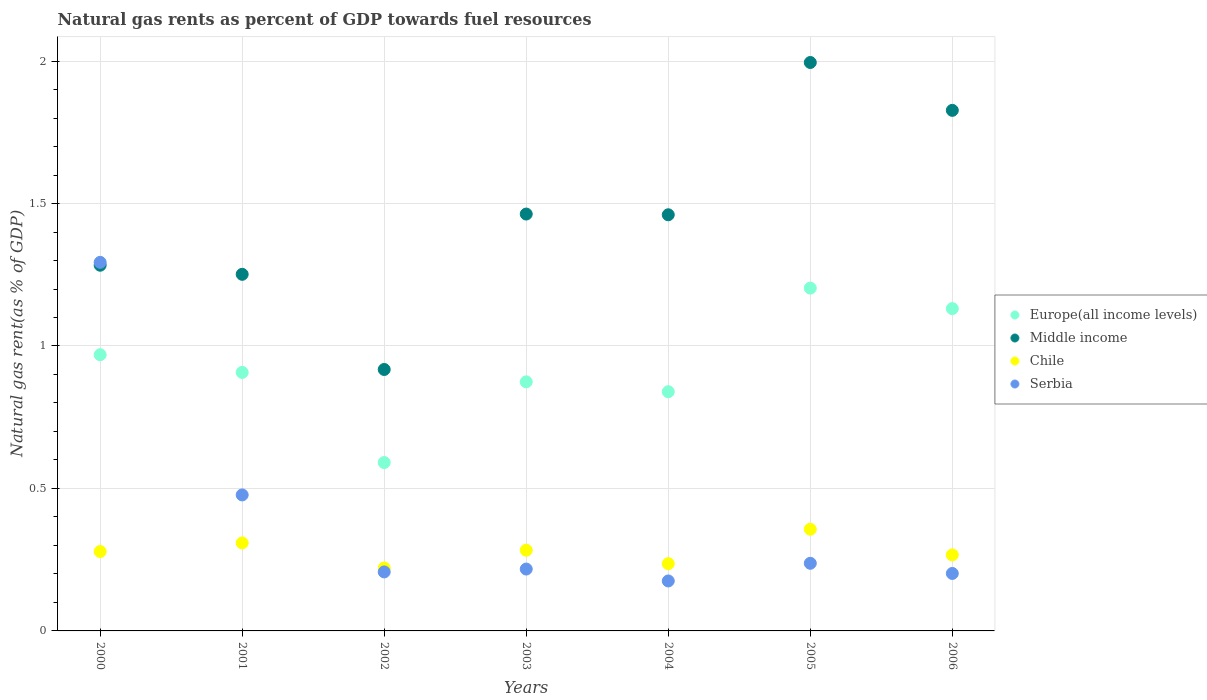How many different coloured dotlines are there?
Provide a succinct answer. 4. Is the number of dotlines equal to the number of legend labels?
Your answer should be compact. Yes. What is the natural gas rent in Serbia in 2002?
Offer a terse response. 0.21. Across all years, what is the maximum natural gas rent in Serbia?
Give a very brief answer. 1.29. Across all years, what is the minimum natural gas rent in Serbia?
Provide a succinct answer. 0.18. What is the total natural gas rent in Europe(all income levels) in the graph?
Ensure brevity in your answer.  6.52. What is the difference between the natural gas rent in Chile in 2001 and that in 2004?
Your response must be concise. 0.07. What is the difference between the natural gas rent in Serbia in 2003 and the natural gas rent in Europe(all income levels) in 2000?
Provide a short and direct response. -0.75. What is the average natural gas rent in Chile per year?
Provide a short and direct response. 0.28. In the year 2001, what is the difference between the natural gas rent in Middle income and natural gas rent in Europe(all income levels)?
Keep it short and to the point. 0.34. What is the ratio of the natural gas rent in Serbia in 2000 to that in 2002?
Your answer should be compact. 6.25. Is the difference between the natural gas rent in Middle income in 2003 and 2005 greater than the difference between the natural gas rent in Europe(all income levels) in 2003 and 2005?
Your answer should be compact. No. What is the difference between the highest and the second highest natural gas rent in Serbia?
Make the answer very short. 0.82. What is the difference between the highest and the lowest natural gas rent in Serbia?
Provide a succinct answer. 1.12. Is the natural gas rent in Europe(all income levels) strictly greater than the natural gas rent in Chile over the years?
Keep it short and to the point. Yes. What is the difference between two consecutive major ticks on the Y-axis?
Offer a terse response. 0.5. Where does the legend appear in the graph?
Your answer should be very brief. Center right. How many legend labels are there?
Ensure brevity in your answer.  4. How are the legend labels stacked?
Keep it short and to the point. Vertical. What is the title of the graph?
Offer a terse response. Natural gas rents as percent of GDP towards fuel resources. What is the label or title of the X-axis?
Ensure brevity in your answer.  Years. What is the label or title of the Y-axis?
Offer a terse response. Natural gas rent(as % of GDP). What is the Natural gas rent(as % of GDP) of Europe(all income levels) in 2000?
Give a very brief answer. 0.97. What is the Natural gas rent(as % of GDP) of Middle income in 2000?
Offer a very short reply. 1.28. What is the Natural gas rent(as % of GDP) in Chile in 2000?
Your answer should be compact. 0.28. What is the Natural gas rent(as % of GDP) of Serbia in 2000?
Provide a short and direct response. 1.29. What is the Natural gas rent(as % of GDP) of Europe(all income levels) in 2001?
Provide a succinct answer. 0.91. What is the Natural gas rent(as % of GDP) in Middle income in 2001?
Keep it short and to the point. 1.25. What is the Natural gas rent(as % of GDP) in Chile in 2001?
Provide a short and direct response. 0.31. What is the Natural gas rent(as % of GDP) of Serbia in 2001?
Provide a short and direct response. 0.48. What is the Natural gas rent(as % of GDP) of Europe(all income levels) in 2002?
Make the answer very short. 0.59. What is the Natural gas rent(as % of GDP) in Middle income in 2002?
Provide a short and direct response. 0.92. What is the Natural gas rent(as % of GDP) in Chile in 2002?
Offer a terse response. 0.22. What is the Natural gas rent(as % of GDP) of Serbia in 2002?
Offer a terse response. 0.21. What is the Natural gas rent(as % of GDP) in Europe(all income levels) in 2003?
Provide a succinct answer. 0.87. What is the Natural gas rent(as % of GDP) in Middle income in 2003?
Give a very brief answer. 1.46. What is the Natural gas rent(as % of GDP) in Chile in 2003?
Offer a very short reply. 0.28. What is the Natural gas rent(as % of GDP) of Serbia in 2003?
Provide a short and direct response. 0.22. What is the Natural gas rent(as % of GDP) of Europe(all income levels) in 2004?
Offer a very short reply. 0.84. What is the Natural gas rent(as % of GDP) in Middle income in 2004?
Your answer should be very brief. 1.46. What is the Natural gas rent(as % of GDP) in Chile in 2004?
Offer a terse response. 0.24. What is the Natural gas rent(as % of GDP) of Serbia in 2004?
Provide a short and direct response. 0.18. What is the Natural gas rent(as % of GDP) in Europe(all income levels) in 2005?
Provide a succinct answer. 1.2. What is the Natural gas rent(as % of GDP) of Middle income in 2005?
Your response must be concise. 1.99. What is the Natural gas rent(as % of GDP) in Chile in 2005?
Offer a terse response. 0.36. What is the Natural gas rent(as % of GDP) in Serbia in 2005?
Provide a succinct answer. 0.24. What is the Natural gas rent(as % of GDP) in Europe(all income levels) in 2006?
Provide a succinct answer. 1.13. What is the Natural gas rent(as % of GDP) of Middle income in 2006?
Offer a very short reply. 1.83. What is the Natural gas rent(as % of GDP) of Chile in 2006?
Provide a succinct answer. 0.27. What is the Natural gas rent(as % of GDP) of Serbia in 2006?
Offer a terse response. 0.2. Across all years, what is the maximum Natural gas rent(as % of GDP) of Europe(all income levels)?
Your answer should be compact. 1.2. Across all years, what is the maximum Natural gas rent(as % of GDP) of Middle income?
Provide a short and direct response. 1.99. Across all years, what is the maximum Natural gas rent(as % of GDP) in Chile?
Your response must be concise. 0.36. Across all years, what is the maximum Natural gas rent(as % of GDP) in Serbia?
Ensure brevity in your answer.  1.29. Across all years, what is the minimum Natural gas rent(as % of GDP) in Europe(all income levels)?
Offer a terse response. 0.59. Across all years, what is the minimum Natural gas rent(as % of GDP) of Middle income?
Your answer should be very brief. 0.92. Across all years, what is the minimum Natural gas rent(as % of GDP) in Chile?
Keep it short and to the point. 0.22. Across all years, what is the minimum Natural gas rent(as % of GDP) of Serbia?
Provide a succinct answer. 0.18. What is the total Natural gas rent(as % of GDP) of Europe(all income levels) in the graph?
Your answer should be compact. 6.52. What is the total Natural gas rent(as % of GDP) in Middle income in the graph?
Provide a succinct answer. 10.2. What is the total Natural gas rent(as % of GDP) in Chile in the graph?
Give a very brief answer. 1.95. What is the total Natural gas rent(as % of GDP) of Serbia in the graph?
Ensure brevity in your answer.  2.81. What is the difference between the Natural gas rent(as % of GDP) of Europe(all income levels) in 2000 and that in 2001?
Your response must be concise. 0.06. What is the difference between the Natural gas rent(as % of GDP) in Middle income in 2000 and that in 2001?
Ensure brevity in your answer.  0.03. What is the difference between the Natural gas rent(as % of GDP) of Chile in 2000 and that in 2001?
Your answer should be compact. -0.03. What is the difference between the Natural gas rent(as % of GDP) of Serbia in 2000 and that in 2001?
Provide a short and direct response. 0.82. What is the difference between the Natural gas rent(as % of GDP) in Europe(all income levels) in 2000 and that in 2002?
Give a very brief answer. 0.38. What is the difference between the Natural gas rent(as % of GDP) of Middle income in 2000 and that in 2002?
Your answer should be very brief. 0.37. What is the difference between the Natural gas rent(as % of GDP) in Chile in 2000 and that in 2002?
Offer a very short reply. 0.06. What is the difference between the Natural gas rent(as % of GDP) in Serbia in 2000 and that in 2002?
Give a very brief answer. 1.09. What is the difference between the Natural gas rent(as % of GDP) of Europe(all income levels) in 2000 and that in 2003?
Provide a succinct answer. 0.1. What is the difference between the Natural gas rent(as % of GDP) in Middle income in 2000 and that in 2003?
Give a very brief answer. -0.18. What is the difference between the Natural gas rent(as % of GDP) of Chile in 2000 and that in 2003?
Provide a succinct answer. -0. What is the difference between the Natural gas rent(as % of GDP) in Serbia in 2000 and that in 2003?
Make the answer very short. 1.08. What is the difference between the Natural gas rent(as % of GDP) of Europe(all income levels) in 2000 and that in 2004?
Your answer should be very brief. 0.13. What is the difference between the Natural gas rent(as % of GDP) in Middle income in 2000 and that in 2004?
Keep it short and to the point. -0.18. What is the difference between the Natural gas rent(as % of GDP) of Chile in 2000 and that in 2004?
Offer a terse response. 0.04. What is the difference between the Natural gas rent(as % of GDP) of Serbia in 2000 and that in 2004?
Provide a succinct answer. 1.12. What is the difference between the Natural gas rent(as % of GDP) of Europe(all income levels) in 2000 and that in 2005?
Give a very brief answer. -0.23. What is the difference between the Natural gas rent(as % of GDP) in Middle income in 2000 and that in 2005?
Give a very brief answer. -0.71. What is the difference between the Natural gas rent(as % of GDP) in Chile in 2000 and that in 2005?
Make the answer very short. -0.08. What is the difference between the Natural gas rent(as % of GDP) of Serbia in 2000 and that in 2005?
Give a very brief answer. 1.06. What is the difference between the Natural gas rent(as % of GDP) in Europe(all income levels) in 2000 and that in 2006?
Provide a succinct answer. -0.16. What is the difference between the Natural gas rent(as % of GDP) of Middle income in 2000 and that in 2006?
Offer a terse response. -0.54. What is the difference between the Natural gas rent(as % of GDP) of Chile in 2000 and that in 2006?
Make the answer very short. 0.01. What is the difference between the Natural gas rent(as % of GDP) of Serbia in 2000 and that in 2006?
Your response must be concise. 1.09. What is the difference between the Natural gas rent(as % of GDP) in Europe(all income levels) in 2001 and that in 2002?
Provide a succinct answer. 0.32. What is the difference between the Natural gas rent(as % of GDP) of Middle income in 2001 and that in 2002?
Your response must be concise. 0.33. What is the difference between the Natural gas rent(as % of GDP) of Chile in 2001 and that in 2002?
Offer a very short reply. 0.09. What is the difference between the Natural gas rent(as % of GDP) of Serbia in 2001 and that in 2002?
Make the answer very short. 0.27. What is the difference between the Natural gas rent(as % of GDP) of Europe(all income levels) in 2001 and that in 2003?
Your response must be concise. 0.03. What is the difference between the Natural gas rent(as % of GDP) in Middle income in 2001 and that in 2003?
Your response must be concise. -0.21. What is the difference between the Natural gas rent(as % of GDP) of Chile in 2001 and that in 2003?
Provide a succinct answer. 0.03. What is the difference between the Natural gas rent(as % of GDP) of Serbia in 2001 and that in 2003?
Provide a short and direct response. 0.26. What is the difference between the Natural gas rent(as % of GDP) in Europe(all income levels) in 2001 and that in 2004?
Provide a succinct answer. 0.07. What is the difference between the Natural gas rent(as % of GDP) of Middle income in 2001 and that in 2004?
Your answer should be compact. -0.21. What is the difference between the Natural gas rent(as % of GDP) of Chile in 2001 and that in 2004?
Provide a succinct answer. 0.07. What is the difference between the Natural gas rent(as % of GDP) in Serbia in 2001 and that in 2004?
Provide a short and direct response. 0.3. What is the difference between the Natural gas rent(as % of GDP) in Europe(all income levels) in 2001 and that in 2005?
Your answer should be compact. -0.3. What is the difference between the Natural gas rent(as % of GDP) in Middle income in 2001 and that in 2005?
Provide a succinct answer. -0.74. What is the difference between the Natural gas rent(as % of GDP) of Chile in 2001 and that in 2005?
Provide a short and direct response. -0.05. What is the difference between the Natural gas rent(as % of GDP) in Serbia in 2001 and that in 2005?
Keep it short and to the point. 0.24. What is the difference between the Natural gas rent(as % of GDP) of Europe(all income levels) in 2001 and that in 2006?
Offer a very short reply. -0.22. What is the difference between the Natural gas rent(as % of GDP) of Middle income in 2001 and that in 2006?
Make the answer very short. -0.58. What is the difference between the Natural gas rent(as % of GDP) in Chile in 2001 and that in 2006?
Provide a succinct answer. 0.04. What is the difference between the Natural gas rent(as % of GDP) in Serbia in 2001 and that in 2006?
Give a very brief answer. 0.28. What is the difference between the Natural gas rent(as % of GDP) in Europe(all income levels) in 2002 and that in 2003?
Your response must be concise. -0.28. What is the difference between the Natural gas rent(as % of GDP) in Middle income in 2002 and that in 2003?
Provide a short and direct response. -0.55. What is the difference between the Natural gas rent(as % of GDP) in Chile in 2002 and that in 2003?
Offer a very short reply. -0.06. What is the difference between the Natural gas rent(as % of GDP) in Serbia in 2002 and that in 2003?
Offer a terse response. -0.01. What is the difference between the Natural gas rent(as % of GDP) in Europe(all income levels) in 2002 and that in 2004?
Give a very brief answer. -0.25. What is the difference between the Natural gas rent(as % of GDP) of Middle income in 2002 and that in 2004?
Ensure brevity in your answer.  -0.54. What is the difference between the Natural gas rent(as % of GDP) of Chile in 2002 and that in 2004?
Give a very brief answer. -0.02. What is the difference between the Natural gas rent(as % of GDP) in Serbia in 2002 and that in 2004?
Provide a short and direct response. 0.03. What is the difference between the Natural gas rent(as % of GDP) of Europe(all income levels) in 2002 and that in 2005?
Make the answer very short. -0.61. What is the difference between the Natural gas rent(as % of GDP) of Middle income in 2002 and that in 2005?
Your answer should be compact. -1.08. What is the difference between the Natural gas rent(as % of GDP) of Chile in 2002 and that in 2005?
Your response must be concise. -0.14. What is the difference between the Natural gas rent(as % of GDP) of Serbia in 2002 and that in 2005?
Provide a succinct answer. -0.03. What is the difference between the Natural gas rent(as % of GDP) in Europe(all income levels) in 2002 and that in 2006?
Make the answer very short. -0.54. What is the difference between the Natural gas rent(as % of GDP) of Middle income in 2002 and that in 2006?
Your answer should be compact. -0.91. What is the difference between the Natural gas rent(as % of GDP) of Chile in 2002 and that in 2006?
Offer a terse response. -0.05. What is the difference between the Natural gas rent(as % of GDP) in Serbia in 2002 and that in 2006?
Offer a very short reply. 0.01. What is the difference between the Natural gas rent(as % of GDP) of Europe(all income levels) in 2003 and that in 2004?
Make the answer very short. 0.03. What is the difference between the Natural gas rent(as % of GDP) of Middle income in 2003 and that in 2004?
Give a very brief answer. 0. What is the difference between the Natural gas rent(as % of GDP) in Chile in 2003 and that in 2004?
Offer a very short reply. 0.05. What is the difference between the Natural gas rent(as % of GDP) in Serbia in 2003 and that in 2004?
Make the answer very short. 0.04. What is the difference between the Natural gas rent(as % of GDP) of Europe(all income levels) in 2003 and that in 2005?
Provide a short and direct response. -0.33. What is the difference between the Natural gas rent(as % of GDP) in Middle income in 2003 and that in 2005?
Provide a succinct answer. -0.53. What is the difference between the Natural gas rent(as % of GDP) in Chile in 2003 and that in 2005?
Offer a terse response. -0.07. What is the difference between the Natural gas rent(as % of GDP) of Serbia in 2003 and that in 2005?
Offer a terse response. -0.02. What is the difference between the Natural gas rent(as % of GDP) of Europe(all income levels) in 2003 and that in 2006?
Provide a succinct answer. -0.26. What is the difference between the Natural gas rent(as % of GDP) in Middle income in 2003 and that in 2006?
Offer a terse response. -0.36. What is the difference between the Natural gas rent(as % of GDP) of Chile in 2003 and that in 2006?
Make the answer very short. 0.02. What is the difference between the Natural gas rent(as % of GDP) in Serbia in 2003 and that in 2006?
Offer a very short reply. 0.02. What is the difference between the Natural gas rent(as % of GDP) of Europe(all income levels) in 2004 and that in 2005?
Provide a succinct answer. -0.36. What is the difference between the Natural gas rent(as % of GDP) in Middle income in 2004 and that in 2005?
Offer a terse response. -0.53. What is the difference between the Natural gas rent(as % of GDP) in Chile in 2004 and that in 2005?
Provide a short and direct response. -0.12. What is the difference between the Natural gas rent(as % of GDP) in Serbia in 2004 and that in 2005?
Keep it short and to the point. -0.06. What is the difference between the Natural gas rent(as % of GDP) in Europe(all income levels) in 2004 and that in 2006?
Your response must be concise. -0.29. What is the difference between the Natural gas rent(as % of GDP) in Middle income in 2004 and that in 2006?
Your answer should be compact. -0.37. What is the difference between the Natural gas rent(as % of GDP) of Chile in 2004 and that in 2006?
Keep it short and to the point. -0.03. What is the difference between the Natural gas rent(as % of GDP) of Serbia in 2004 and that in 2006?
Offer a very short reply. -0.03. What is the difference between the Natural gas rent(as % of GDP) in Europe(all income levels) in 2005 and that in 2006?
Offer a terse response. 0.07. What is the difference between the Natural gas rent(as % of GDP) in Middle income in 2005 and that in 2006?
Ensure brevity in your answer.  0.17. What is the difference between the Natural gas rent(as % of GDP) in Chile in 2005 and that in 2006?
Your response must be concise. 0.09. What is the difference between the Natural gas rent(as % of GDP) in Serbia in 2005 and that in 2006?
Keep it short and to the point. 0.04. What is the difference between the Natural gas rent(as % of GDP) in Europe(all income levels) in 2000 and the Natural gas rent(as % of GDP) in Middle income in 2001?
Offer a very short reply. -0.28. What is the difference between the Natural gas rent(as % of GDP) in Europe(all income levels) in 2000 and the Natural gas rent(as % of GDP) in Chile in 2001?
Your answer should be very brief. 0.66. What is the difference between the Natural gas rent(as % of GDP) of Europe(all income levels) in 2000 and the Natural gas rent(as % of GDP) of Serbia in 2001?
Your response must be concise. 0.49. What is the difference between the Natural gas rent(as % of GDP) of Middle income in 2000 and the Natural gas rent(as % of GDP) of Chile in 2001?
Keep it short and to the point. 0.97. What is the difference between the Natural gas rent(as % of GDP) in Middle income in 2000 and the Natural gas rent(as % of GDP) in Serbia in 2001?
Provide a succinct answer. 0.81. What is the difference between the Natural gas rent(as % of GDP) of Chile in 2000 and the Natural gas rent(as % of GDP) of Serbia in 2001?
Keep it short and to the point. -0.2. What is the difference between the Natural gas rent(as % of GDP) in Europe(all income levels) in 2000 and the Natural gas rent(as % of GDP) in Middle income in 2002?
Offer a terse response. 0.05. What is the difference between the Natural gas rent(as % of GDP) in Europe(all income levels) in 2000 and the Natural gas rent(as % of GDP) in Chile in 2002?
Offer a terse response. 0.75. What is the difference between the Natural gas rent(as % of GDP) of Europe(all income levels) in 2000 and the Natural gas rent(as % of GDP) of Serbia in 2002?
Make the answer very short. 0.76. What is the difference between the Natural gas rent(as % of GDP) of Middle income in 2000 and the Natural gas rent(as % of GDP) of Serbia in 2002?
Keep it short and to the point. 1.08. What is the difference between the Natural gas rent(as % of GDP) in Chile in 2000 and the Natural gas rent(as % of GDP) in Serbia in 2002?
Offer a terse response. 0.07. What is the difference between the Natural gas rent(as % of GDP) of Europe(all income levels) in 2000 and the Natural gas rent(as % of GDP) of Middle income in 2003?
Make the answer very short. -0.49. What is the difference between the Natural gas rent(as % of GDP) in Europe(all income levels) in 2000 and the Natural gas rent(as % of GDP) in Chile in 2003?
Provide a short and direct response. 0.69. What is the difference between the Natural gas rent(as % of GDP) in Europe(all income levels) in 2000 and the Natural gas rent(as % of GDP) in Serbia in 2003?
Ensure brevity in your answer.  0.75. What is the difference between the Natural gas rent(as % of GDP) of Middle income in 2000 and the Natural gas rent(as % of GDP) of Chile in 2003?
Provide a succinct answer. 1. What is the difference between the Natural gas rent(as % of GDP) in Middle income in 2000 and the Natural gas rent(as % of GDP) in Serbia in 2003?
Your answer should be very brief. 1.07. What is the difference between the Natural gas rent(as % of GDP) in Chile in 2000 and the Natural gas rent(as % of GDP) in Serbia in 2003?
Your answer should be very brief. 0.06. What is the difference between the Natural gas rent(as % of GDP) of Europe(all income levels) in 2000 and the Natural gas rent(as % of GDP) of Middle income in 2004?
Your answer should be very brief. -0.49. What is the difference between the Natural gas rent(as % of GDP) of Europe(all income levels) in 2000 and the Natural gas rent(as % of GDP) of Chile in 2004?
Your answer should be compact. 0.73. What is the difference between the Natural gas rent(as % of GDP) in Europe(all income levels) in 2000 and the Natural gas rent(as % of GDP) in Serbia in 2004?
Your answer should be very brief. 0.79. What is the difference between the Natural gas rent(as % of GDP) of Middle income in 2000 and the Natural gas rent(as % of GDP) of Chile in 2004?
Ensure brevity in your answer.  1.05. What is the difference between the Natural gas rent(as % of GDP) in Middle income in 2000 and the Natural gas rent(as % of GDP) in Serbia in 2004?
Provide a succinct answer. 1.11. What is the difference between the Natural gas rent(as % of GDP) of Chile in 2000 and the Natural gas rent(as % of GDP) of Serbia in 2004?
Make the answer very short. 0.1. What is the difference between the Natural gas rent(as % of GDP) in Europe(all income levels) in 2000 and the Natural gas rent(as % of GDP) in Middle income in 2005?
Your response must be concise. -1.03. What is the difference between the Natural gas rent(as % of GDP) in Europe(all income levels) in 2000 and the Natural gas rent(as % of GDP) in Chile in 2005?
Ensure brevity in your answer.  0.61. What is the difference between the Natural gas rent(as % of GDP) of Europe(all income levels) in 2000 and the Natural gas rent(as % of GDP) of Serbia in 2005?
Keep it short and to the point. 0.73. What is the difference between the Natural gas rent(as % of GDP) of Middle income in 2000 and the Natural gas rent(as % of GDP) of Chile in 2005?
Your answer should be very brief. 0.93. What is the difference between the Natural gas rent(as % of GDP) of Middle income in 2000 and the Natural gas rent(as % of GDP) of Serbia in 2005?
Offer a terse response. 1.05. What is the difference between the Natural gas rent(as % of GDP) in Chile in 2000 and the Natural gas rent(as % of GDP) in Serbia in 2005?
Ensure brevity in your answer.  0.04. What is the difference between the Natural gas rent(as % of GDP) of Europe(all income levels) in 2000 and the Natural gas rent(as % of GDP) of Middle income in 2006?
Give a very brief answer. -0.86. What is the difference between the Natural gas rent(as % of GDP) in Europe(all income levels) in 2000 and the Natural gas rent(as % of GDP) in Chile in 2006?
Make the answer very short. 0.7. What is the difference between the Natural gas rent(as % of GDP) of Europe(all income levels) in 2000 and the Natural gas rent(as % of GDP) of Serbia in 2006?
Your response must be concise. 0.77. What is the difference between the Natural gas rent(as % of GDP) in Middle income in 2000 and the Natural gas rent(as % of GDP) in Chile in 2006?
Offer a very short reply. 1.02. What is the difference between the Natural gas rent(as % of GDP) of Middle income in 2000 and the Natural gas rent(as % of GDP) of Serbia in 2006?
Offer a very short reply. 1.08. What is the difference between the Natural gas rent(as % of GDP) of Chile in 2000 and the Natural gas rent(as % of GDP) of Serbia in 2006?
Give a very brief answer. 0.08. What is the difference between the Natural gas rent(as % of GDP) of Europe(all income levels) in 2001 and the Natural gas rent(as % of GDP) of Middle income in 2002?
Keep it short and to the point. -0.01. What is the difference between the Natural gas rent(as % of GDP) in Europe(all income levels) in 2001 and the Natural gas rent(as % of GDP) in Chile in 2002?
Keep it short and to the point. 0.69. What is the difference between the Natural gas rent(as % of GDP) of Europe(all income levels) in 2001 and the Natural gas rent(as % of GDP) of Serbia in 2002?
Make the answer very short. 0.7. What is the difference between the Natural gas rent(as % of GDP) in Middle income in 2001 and the Natural gas rent(as % of GDP) in Chile in 2002?
Your answer should be very brief. 1.03. What is the difference between the Natural gas rent(as % of GDP) of Middle income in 2001 and the Natural gas rent(as % of GDP) of Serbia in 2002?
Offer a terse response. 1.04. What is the difference between the Natural gas rent(as % of GDP) in Chile in 2001 and the Natural gas rent(as % of GDP) in Serbia in 2002?
Your response must be concise. 0.1. What is the difference between the Natural gas rent(as % of GDP) in Europe(all income levels) in 2001 and the Natural gas rent(as % of GDP) in Middle income in 2003?
Your response must be concise. -0.56. What is the difference between the Natural gas rent(as % of GDP) of Europe(all income levels) in 2001 and the Natural gas rent(as % of GDP) of Chile in 2003?
Give a very brief answer. 0.62. What is the difference between the Natural gas rent(as % of GDP) of Europe(all income levels) in 2001 and the Natural gas rent(as % of GDP) of Serbia in 2003?
Your answer should be very brief. 0.69. What is the difference between the Natural gas rent(as % of GDP) in Middle income in 2001 and the Natural gas rent(as % of GDP) in Chile in 2003?
Your answer should be very brief. 0.97. What is the difference between the Natural gas rent(as % of GDP) of Middle income in 2001 and the Natural gas rent(as % of GDP) of Serbia in 2003?
Give a very brief answer. 1.03. What is the difference between the Natural gas rent(as % of GDP) of Chile in 2001 and the Natural gas rent(as % of GDP) of Serbia in 2003?
Make the answer very short. 0.09. What is the difference between the Natural gas rent(as % of GDP) in Europe(all income levels) in 2001 and the Natural gas rent(as % of GDP) in Middle income in 2004?
Your answer should be compact. -0.55. What is the difference between the Natural gas rent(as % of GDP) in Europe(all income levels) in 2001 and the Natural gas rent(as % of GDP) in Chile in 2004?
Make the answer very short. 0.67. What is the difference between the Natural gas rent(as % of GDP) in Europe(all income levels) in 2001 and the Natural gas rent(as % of GDP) in Serbia in 2004?
Give a very brief answer. 0.73. What is the difference between the Natural gas rent(as % of GDP) in Middle income in 2001 and the Natural gas rent(as % of GDP) in Chile in 2004?
Offer a very short reply. 1.02. What is the difference between the Natural gas rent(as % of GDP) in Middle income in 2001 and the Natural gas rent(as % of GDP) in Serbia in 2004?
Provide a succinct answer. 1.08. What is the difference between the Natural gas rent(as % of GDP) in Chile in 2001 and the Natural gas rent(as % of GDP) in Serbia in 2004?
Your answer should be compact. 0.13. What is the difference between the Natural gas rent(as % of GDP) of Europe(all income levels) in 2001 and the Natural gas rent(as % of GDP) of Middle income in 2005?
Your response must be concise. -1.09. What is the difference between the Natural gas rent(as % of GDP) in Europe(all income levels) in 2001 and the Natural gas rent(as % of GDP) in Chile in 2005?
Give a very brief answer. 0.55. What is the difference between the Natural gas rent(as % of GDP) in Europe(all income levels) in 2001 and the Natural gas rent(as % of GDP) in Serbia in 2005?
Provide a short and direct response. 0.67. What is the difference between the Natural gas rent(as % of GDP) of Middle income in 2001 and the Natural gas rent(as % of GDP) of Chile in 2005?
Provide a succinct answer. 0.89. What is the difference between the Natural gas rent(as % of GDP) of Middle income in 2001 and the Natural gas rent(as % of GDP) of Serbia in 2005?
Make the answer very short. 1.01. What is the difference between the Natural gas rent(as % of GDP) in Chile in 2001 and the Natural gas rent(as % of GDP) in Serbia in 2005?
Keep it short and to the point. 0.07. What is the difference between the Natural gas rent(as % of GDP) of Europe(all income levels) in 2001 and the Natural gas rent(as % of GDP) of Middle income in 2006?
Ensure brevity in your answer.  -0.92. What is the difference between the Natural gas rent(as % of GDP) in Europe(all income levels) in 2001 and the Natural gas rent(as % of GDP) in Chile in 2006?
Your response must be concise. 0.64. What is the difference between the Natural gas rent(as % of GDP) of Europe(all income levels) in 2001 and the Natural gas rent(as % of GDP) of Serbia in 2006?
Offer a very short reply. 0.71. What is the difference between the Natural gas rent(as % of GDP) in Middle income in 2001 and the Natural gas rent(as % of GDP) in Chile in 2006?
Your answer should be compact. 0.98. What is the difference between the Natural gas rent(as % of GDP) of Middle income in 2001 and the Natural gas rent(as % of GDP) of Serbia in 2006?
Offer a very short reply. 1.05. What is the difference between the Natural gas rent(as % of GDP) in Chile in 2001 and the Natural gas rent(as % of GDP) in Serbia in 2006?
Provide a succinct answer. 0.11. What is the difference between the Natural gas rent(as % of GDP) of Europe(all income levels) in 2002 and the Natural gas rent(as % of GDP) of Middle income in 2003?
Your answer should be compact. -0.87. What is the difference between the Natural gas rent(as % of GDP) in Europe(all income levels) in 2002 and the Natural gas rent(as % of GDP) in Chile in 2003?
Provide a short and direct response. 0.31. What is the difference between the Natural gas rent(as % of GDP) of Europe(all income levels) in 2002 and the Natural gas rent(as % of GDP) of Serbia in 2003?
Your answer should be compact. 0.37. What is the difference between the Natural gas rent(as % of GDP) of Middle income in 2002 and the Natural gas rent(as % of GDP) of Chile in 2003?
Provide a succinct answer. 0.63. What is the difference between the Natural gas rent(as % of GDP) of Middle income in 2002 and the Natural gas rent(as % of GDP) of Serbia in 2003?
Ensure brevity in your answer.  0.7. What is the difference between the Natural gas rent(as % of GDP) in Chile in 2002 and the Natural gas rent(as % of GDP) in Serbia in 2003?
Keep it short and to the point. 0. What is the difference between the Natural gas rent(as % of GDP) of Europe(all income levels) in 2002 and the Natural gas rent(as % of GDP) of Middle income in 2004?
Make the answer very short. -0.87. What is the difference between the Natural gas rent(as % of GDP) of Europe(all income levels) in 2002 and the Natural gas rent(as % of GDP) of Chile in 2004?
Your answer should be compact. 0.35. What is the difference between the Natural gas rent(as % of GDP) in Europe(all income levels) in 2002 and the Natural gas rent(as % of GDP) in Serbia in 2004?
Keep it short and to the point. 0.42. What is the difference between the Natural gas rent(as % of GDP) of Middle income in 2002 and the Natural gas rent(as % of GDP) of Chile in 2004?
Your response must be concise. 0.68. What is the difference between the Natural gas rent(as % of GDP) of Middle income in 2002 and the Natural gas rent(as % of GDP) of Serbia in 2004?
Your answer should be compact. 0.74. What is the difference between the Natural gas rent(as % of GDP) in Chile in 2002 and the Natural gas rent(as % of GDP) in Serbia in 2004?
Your answer should be very brief. 0.05. What is the difference between the Natural gas rent(as % of GDP) of Europe(all income levels) in 2002 and the Natural gas rent(as % of GDP) of Middle income in 2005?
Give a very brief answer. -1.4. What is the difference between the Natural gas rent(as % of GDP) in Europe(all income levels) in 2002 and the Natural gas rent(as % of GDP) in Chile in 2005?
Keep it short and to the point. 0.23. What is the difference between the Natural gas rent(as % of GDP) of Europe(all income levels) in 2002 and the Natural gas rent(as % of GDP) of Serbia in 2005?
Make the answer very short. 0.35. What is the difference between the Natural gas rent(as % of GDP) in Middle income in 2002 and the Natural gas rent(as % of GDP) in Chile in 2005?
Make the answer very short. 0.56. What is the difference between the Natural gas rent(as % of GDP) in Middle income in 2002 and the Natural gas rent(as % of GDP) in Serbia in 2005?
Your answer should be very brief. 0.68. What is the difference between the Natural gas rent(as % of GDP) in Chile in 2002 and the Natural gas rent(as % of GDP) in Serbia in 2005?
Keep it short and to the point. -0.02. What is the difference between the Natural gas rent(as % of GDP) of Europe(all income levels) in 2002 and the Natural gas rent(as % of GDP) of Middle income in 2006?
Offer a terse response. -1.24. What is the difference between the Natural gas rent(as % of GDP) of Europe(all income levels) in 2002 and the Natural gas rent(as % of GDP) of Chile in 2006?
Give a very brief answer. 0.32. What is the difference between the Natural gas rent(as % of GDP) of Europe(all income levels) in 2002 and the Natural gas rent(as % of GDP) of Serbia in 2006?
Offer a very short reply. 0.39. What is the difference between the Natural gas rent(as % of GDP) of Middle income in 2002 and the Natural gas rent(as % of GDP) of Chile in 2006?
Offer a terse response. 0.65. What is the difference between the Natural gas rent(as % of GDP) of Middle income in 2002 and the Natural gas rent(as % of GDP) of Serbia in 2006?
Your answer should be compact. 0.72. What is the difference between the Natural gas rent(as % of GDP) of Chile in 2002 and the Natural gas rent(as % of GDP) of Serbia in 2006?
Offer a terse response. 0.02. What is the difference between the Natural gas rent(as % of GDP) in Europe(all income levels) in 2003 and the Natural gas rent(as % of GDP) in Middle income in 2004?
Keep it short and to the point. -0.59. What is the difference between the Natural gas rent(as % of GDP) in Europe(all income levels) in 2003 and the Natural gas rent(as % of GDP) in Chile in 2004?
Provide a short and direct response. 0.64. What is the difference between the Natural gas rent(as % of GDP) of Europe(all income levels) in 2003 and the Natural gas rent(as % of GDP) of Serbia in 2004?
Offer a very short reply. 0.7. What is the difference between the Natural gas rent(as % of GDP) of Middle income in 2003 and the Natural gas rent(as % of GDP) of Chile in 2004?
Your answer should be very brief. 1.23. What is the difference between the Natural gas rent(as % of GDP) in Middle income in 2003 and the Natural gas rent(as % of GDP) in Serbia in 2004?
Your answer should be compact. 1.29. What is the difference between the Natural gas rent(as % of GDP) of Chile in 2003 and the Natural gas rent(as % of GDP) of Serbia in 2004?
Make the answer very short. 0.11. What is the difference between the Natural gas rent(as % of GDP) of Europe(all income levels) in 2003 and the Natural gas rent(as % of GDP) of Middle income in 2005?
Offer a very short reply. -1.12. What is the difference between the Natural gas rent(as % of GDP) in Europe(all income levels) in 2003 and the Natural gas rent(as % of GDP) in Chile in 2005?
Give a very brief answer. 0.52. What is the difference between the Natural gas rent(as % of GDP) of Europe(all income levels) in 2003 and the Natural gas rent(as % of GDP) of Serbia in 2005?
Keep it short and to the point. 0.64. What is the difference between the Natural gas rent(as % of GDP) of Middle income in 2003 and the Natural gas rent(as % of GDP) of Chile in 2005?
Make the answer very short. 1.11. What is the difference between the Natural gas rent(as % of GDP) of Middle income in 2003 and the Natural gas rent(as % of GDP) of Serbia in 2005?
Offer a terse response. 1.23. What is the difference between the Natural gas rent(as % of GDP) of Chile in 2003 and the Natural gas rent(as % of GDP) of Serbia in 2005?
Provide a short and direct response. 0.05. What is the difference between the Natural gas rent(as % of GDP) of Europe(all income levels) in 2003 and the Natural gas rent(as % of GDP) of Middle income in 2006?
Provide a short and direct response. -0.95. What is the difference between the Natural gas rent(as % of GDP) of Europe(all income levels) in 2003 and the Natural gas rent(as % of GDP) of Chile in 2006?
Give a very brief answer. 0.61. What is the difference between the Natural gas rent(as % of GDP) in Europe(all income levels) in 2003 and the Natural gas rent(as % of GDP) in Serbia in 2006?
Your response must be concise. 0.67. What is the difference between the Natural gas rent(as % of GDP) in Middle income in 2003 and the Natural gas rent(as % of GDP) in Chile in 2006?
Give a very brief answer. 1.2. What is the difference between the Natural gas rent(as % of GDP) of Middle income in 2003 and the Natural gas rent(as % of GDP) of Serbia in 2006?
Provide a short and direct response. 1.26. What is the difference between the Natural gas rent(as % of GDP) of Chile in 2003 and the Natural gas rent(as % of GDP) of Serbia in 2006?
Ensure brevity in your answer.  0.08. What is the difference between the Natural gas rent(as % of GDP) in Europe(all income levels) in 2004 and the Natural gas rent(as % of GDP) in Middle income in 2005?
Provide a short and direct response. -1.16. What is the difference between the Natural gas rent(as % of GDP) in Europe(all income levels) in 2004 and the Natural gas rent(as % of GDP) in Chile in 2005?
Provide a short and direct response. 0.48. What is the difference between the Natural gas rent(as % of GDP) of Europe(all income levels) in 2004 and the Natural gas rent(as % of GDP) of Serbia in 2005?
Provide a short and direct response. 0.6. What is the difference between the Natural gas rent(as % of GDP) of Middle income in 2004 and the Natural gas rent(as % of GDP) of Chile in 2005?
Make the answer very short. 1.1. What is the difference between the Natural gas rent(as % of GDP) of Middle income in 2004 and the Natural gas rent(as % of GDP) of Serbia in 2005?
Your response must be concise. 1.22. What is the difference between the Natural gas rent(as % of GDP) in Chile in 2004 and the Natural gas rent(as % of GDP) in Serbia in 2005?
Your answer should be very brief. -0. What is the difference between the Natural gas rent(as % of GDP) in Europe(all income levels) in 2004 and the Natural gas rent(as % of GDP) in Middle income in 2006?
Keep it short and to the point. -0.99. What is the difference between the Natural gas rent(as % of GDP) of Europe(all income levels) in 2004 and the Natural gas rent(as % of GDP) of Chile in 2006?
Ensure brevity in your answer.  0.57. What is the difference between the Natural gas rent(as % of GDP) of Europe(all income levels) in 2004 and the Natural gas rent(as % of GDP) of Serbia in 2006?
Your answer should be very brief. 0.64. What is the difference between the Natural gas rent(as % of GDP) in Middle income in 2004 and the Natural gas rent(as % of GDP) in Chile in 2006?
Offer a very short reply. 1.19. What is the difference between the Natural gas rent(as % of GDP) in Middle income in 2004 and the Natural gas rent(as % of GDP) in Serbia in 2006?
Ensure brevity in your answer.  1.26. What is the difference between the Natural gas rent(as % of GDP) in Chile in 2004 and the Natural gas rent(as % of GDP) in Serbia in 2006?
Your answer should be very brief. 0.03. What is the difference between the Natural gas rent(as % of GDP) of Europe(all income levels) in 2005 and the Natural gas rent(as % of GDP) of Middle income in 2006?
Make the answer very short. -0.62. What is the difference between the Natural gas rent(as % of GDP) in Europe(all income levels) in 2005 and the Natural gas rent(as % of GDP) in Chile in 2006?
Make the answer very short. 0.94. What is the difference between the Natural gas rent(as % of GDP) of Middle income in 2005 and the Natural gas rent(as % of GDP) of Chile in 2006?
Your answer should be compact. 1.73. What is the difference between the Natural gas rent(as % of GDP) of Middle income in 2005 and the Natural gas rent(as % of GDP) of Serbia in 2006?
Your answer should be compact. 1.79. What is the difference between the Natural gas rent(as % of GDP) in Chile in 2005 and the Natural gas rent(as % of GDP) in Serbia in 2006?
Your response must be concise. 0.16. What is the average Natural gas rent(as % of GDP) in Europe(all income levels) per year?
Your response must be concise. 0.93. What is the average Natural gas rent(as % of GDP) in Middle income per year?
Keep it short and to the point. 1.46. What is the average Natural gas rent(as % of GDP) of Chile per year?
Provide a short and direct response. 0.28. What is the average Natural gas rent(as % of GDP) of Serbia per year?
Give a very brief answer. 0.4. In the year 2000, what is the difference between the Natural gas rent(as % of GDP) of Europe(all income levels) and Natural gas rent(as % of GDP) of Middle income?
Give a very brief answer. -0.31. In the year 2000, what is the difference between the Natural gas rent(as % of GDP) of Europe(all income levels) and Natural gas rent(as % of GDP) of Chile?
Keep it short and to the point. 0.69. In the year 2000, what is the difference between the Natural gas rent(as % of GDP) in Europe(all income levels) and Natural gas rent(as % of GDP) in Serbia?
Keep it short and to the point. -0.32. In the year 2000, what is the difference between the Natural gas rent(as % of GDP) of Middle income and Natural gas rent(as % of GDP) of Serbia?
Ensure brevity in your answer.  -0.01. In the year 2000, what is the difference between the Natural gas rent(as % of GDP) in Chile and Natural gas rent(as % of GDP) in Serbia?
Your response must be concise. -1.01. In the year 2001, what is the difference between the Natural gas rent(as % of GDP) of Europe(all income levels) and Natural gas rent(as % of GDP) of Middle income?
Make the answer very short. -0.34. In the year 2001, what is the difference between the Natural gas rent(as % of GDP) of Europe(all income levels) and Natural gas rent(as % of GDP) of Chile?
Your answer should be very brief. 0.6. In the year 2001, what is the difference between the Natural gas rent(as % of GDP) of Europe(all income levels) and Natural gas rent(as % of GDP) of Serbia?
Ensure brevity in your answer.  0.43. In the year 2001, what is the difference between the Natural gas rent(as % of GDP) of Middle income and Natural gas rent(as % of GDP) of Chile?
Make the answer very short. 0.94. In the year 2001, what is the difference between the Natural gas rent(as % of GDP) of Middle income and Natural gas rent(as % of GDP) of Serbia?
Your response must be concise. 0.77. In the year 2001, what is the difference between the Natural gas rent(as % of GDP) in Chile and Natural gas rent(as % of GDP) in Serbia?
Your answer should be compact. -0.17. In the year 2002, what is the difference between the Natural gas rent(as % of GDP) in Europe(all income levels) and Natural gas rent(as % of GDP) in Middle income?
Your answer should be compact. -0.33. In the year 2002, what is the difference between the Natural gas rent(as % of GDP) in Europe(all income levels) and Natural gas rent(as % of GDP) in Chile?
Keep it short and to the point. 0.37. In the year 2002, what is the difference between the Natural gas rent(as % of GDP) in Europe(all income levels) and Natural gas rent(as % of GDP) in Serbia?
Provide a short and direct response. 0.38. In the year 2002, what is the difference between the Natural gas rent(as % of GDP) in Middle income and Natural gas rent(as % of GDP) in Chile?
Ensure brevity in your answer.  0.7. In the year 2002, what is the difference between the Natural gas rent(as % of GDP) of Middle income and Natural gas rent(as % of GDP) of Serbia?
Your response must be concise. 0.71. In the year 2002, what is the difference between the Natural gas rent(as % of GDP) of Chile and Natural gas rent(as % of GDP) of Serbia?
Your answer should be very brief. 0.01. In the year 2003, what is the difference between the Natural gas rent(as % of GDP) of Europe(all income levels) and Natural gas rent(as % of GDP) of Middle income?
Ensure brevity in your answer.  -0.59. In the year 2003, what is the difference between the Natural gas rent(as % of GDP) of Europe(all income levels) and Natural gas rent(as % of GDP) of Chile?
Offer a very short reply. 0.59. In the year 2003, what is the difference between the Natural gas rent(as % of GDP) in Europe(all income levels) and Natural gas rent(as % of GDP) in Serbia?
Keep it short and to the point. 0.66. In the year 2003, what is the difference between the Natural gas rent(as % of GDP) in Middle income and Natural gas rent(as % of GDP) in Chile?
Ensure brevity in your answer.  1.18. In the year 2003, what is the difference between the Natural gas rent(as % of GDP) in Middle income and Natural gas rent(as % of GDP) in Serbia?
Offer a very short reply. 1.25. In the year 2003, what is the difference between the Natural gas rent(as % of GDP) in Chile and Natural gas rent(as % of GDP) in Serbia?
Your response must be concise. 0.07. In the year 2004, what is the difference between the Natural gas rent(as % of GDP) of Europe(all income levels) and Natural gas rent(as % of GDP) of Middle income?
Your response must be concise. -0.62. In the year 2004, what is the difference between the Natural gas rent(as % of GDP) in Europe(all income levels) and Natural gas rent(as % of GDP) in Chile?
Keep it short and to the point. 0.6. In the year 2004, what is the difference between the Natural gas rent(as % of GDP) in Europe(all income levels) and Natural gas rent(as % of GDP) in Serbia?
Your answer should be compact. 0.66. In the year 2004, what is the difference between the Natural gas rent(as % of GDP) of Middle income and Natural gas rent(as % of GDP) of Chile?
Offer a terse response. 1.22. In the year 2004, what is the difference between the Natural gas rent(as % of GDP) in Middle income and Natural gas rent(as % of GDP) in Serbia?
Give a very brief answer. 1.29. In the year 2004, what is the difference between the Natural gas rent(as % of GDP) of Chile and Natural gas rent(as % of GDP) of Serbia?
Give a very brief answer. 0.06. In the year 2005, what is the difference between the Natural gas rent(as % of GDP) in Europe(all income levels) and Natural gas rent(as % of GDP) in Middle income?
Provide a succinct answer. -0.79. In the year 2005, what is the difference between the Natural gas rent(as % of GDP) in Europe(all income levels) and Natural gas rent(as % of GDP) in Chile?
Offer a terse response. 0.85. In the year 2005, what is the difference between the Natural gas rent(as % of GDP) of Europe(all income levels) and Natural gas rent(as % of GDP) of Serbia?
Give a very brief answer. 0.97. In the year 2005, what is the difference between the Natural gas rent(as % of GDP) of Middle income and Natural gas rent(as % of GDP) of Chile?
Provide a short and direct response. 1.64. In the year 2005, what is the difference between the Natural gas rent(as % of GDP) of Middle income and Natural gas rent(as % of GDP) of Serbia?
Provide a short and direct response. 1.76. In the year 2005, what is the difference between the Natural gas rent(as % of GDP) in Chile and Natural gas rent(as % of GDP) in Serbia?
Give a very brief answer. 0.12. In the year 2006, what is the difference between the Natural gas rent(as % of GDP) in Europe(all income levels) and Natural gas rent(as % of GDP) in Middle income?
Provide a short and direct response. -0.7. In the year 2006, what is the difference between the Natural gas rent(as % of GDP) in Europe(all income levels) and Natural gas rent(as % of GDP) in Chile?
Provide a succinct answer. 0.86. In the year 2006, what is the difference between the Natural gas rent(as % of GDP) in Europe(all income levels) and Natural gas rent(as % of GDP) in Serbia?
Your response must be concise. 0.93. In the year 2006, what is the difference between the Natural gas rent(as % of GDP) in Middle income and Natural gas rent(as % of GDP) in Chile?
Your answer should be compact. 1.56. In the year 2006, what is the difference between the Natural gas rent(as % of GDP) of Middle income and Natural gas rent(as % of GDP) of Serbia?
Your answer should be compact. 1.63. In the year 2006, what is the difference between the Natural gas rent(as % of GDP) in Chile and Natural gas rent(as % of GDP) in Serbia?
Offer a terse response. 0.07. What is the ratio of the Natural gas rent(as % of GDP) in Europe(all income levels) in 2000 to that in 2001?
Your answer should be very brief. 1.07. What is the ratio of the Natural gas rent(as % of GDP) of Middle income in 2000 to that in 2001?
Keep it short and to the point. 1.03. What is the ratio of the Natural gas rent(as % of GDP) in Chile in 2000 to that in 2001?
Provide a short and direct response. 0.9. What is the ratio of the Natural gas rent(as % of GDP) of Serbia in 2000 to that in 2001?
Provide a short and direct response. 2.71. What is the ratio of the Natural gas rent(as % of GDP) of Europe(all income levels) in 2000 to that in 2002?
Your response must be concise. 1.64. What is the ratio of the Natural gas rent(as % of GDP) of Middle income in 2000 to that in 2002?
Your answer should be compact. 1.4. What is the ratio of the Natural gas rent(as % of GDP) of Chile in 2000 to that in 2002?
Ensure brevity in your answer.  1.26. What is the ratio of the Natural gas rent(as % of GDP) of Serbia in 2000 to that in 2002?
Provide a succinct answer. 6.25. What is the ratio of the Natural gas rent(as % of GDP) of Europe(all income levels) in 2000 to that in 2003?
Provide a short and direct response. 1.11. What is the ratio of the Natural gas rent(as % of GDP) in Middle income in 2000 to that in 2003?
Offer a very short reply. 0.88. What is the ratio of the Natural gas rent(as % of GDP) in Chile in 2000 to that in 2003?
Ensure brevity in your answer.  0.98. What is the ratio of the Natural gas rent(as % of GDP) in Serbia in 2000 to that in 2003?
Make the answer very short. 5.96. What is the ratio of the Natural gas rent(as % of GDP) of Europe(all income levels) in 2000 to that in 2004?
Keep it short and to the point. 1.15. What is the ratio of the Natural gas rent(as % of GDP) of Middle income in 2000 to that in 2004?
Offer a terse response. 0.88. What is the ratio of the Natural gas rent(as % of GDP) in Chile in 2000 to that in 2004?
Offer a very short reply. 1.18. What is the ratio of the Natural gas rent(as % of GDP) of Serbia in 2000 to that in 2004?
Give a very brief answer. 7.38. What is the ratio of the Natural gas rent(as % of GDP) of Europe(all income levels) in 2000 to that in 2005?
Keep it short and to the point. 0.81. What is the ratio of the Natural gas rent(as % of GDP) of Middle income in 2000 to that in 2005?
Keep it short and to the point. 0.64. What is the ratio of the Natural gas rent(as % of GDP) of Chile in 2000 to that in 2005?
Your response must be concise. 0.78. What is the ratio of the Natural gas rent(as % of GDP) of Serbia in 2000 to that in 2005?
Provide a succinct answer. 5.45. What is the ratio of the Natural gas rent(as % of GDP) of Europe(all income levels) in 2000 to that in 2006?
Make the answer very short. 0.86. What is the ratio of the Natural gas rent(as % of GDP) of Middle income in 2000 to that in 2006?
Your response must be concise. 0.7. What is the ratio of the Natural gas rent(as % of GDP) of Chile in 2000 to that in 2006?
Your answer should be very brief. 1.04. What is the ratio of the Natural gas rent(as % of GDP) of Serbia in 2000 to that in 2006?
Your answer should be very brief. 6.41. What is the ratio of the Natural gas rent(as % of GDP) in Europe(all income levels) in 2001 to that in 2002?
Ensure brevity in your answer.  1.54. What is the ratio of the Natural gas rent(as % of GDP) in Middle income in 2001 to that in 2002?
Offer a very short reply. 1.36. What is the ratio of the Natural gas rent(as % of GDP) of Chile in 2001 to that in 2002?
Give a very brief answer. 1.4. What is the ratio of the Natural gas rent(as % of GDP) of Serbia in 2001 to that in 2002?
Ensure brevity in your answer.  2.31. What is the ratio of the Natural gas rent(as % of GDP) of Europe(all income levels) in 2001 to that in 2003?
Give a very brief answer. 1.04. What is the ratio of the Natural gas rent(as % of GDP) of Middle income in 2001 to that in 2003?
Offer a terse response. 0.86. What is the ratio of the Natural gas rent(as % of GDP) in Chile in 2001 to that in 2003?
Ensure brevity in your answer.  1.09. What is the ratio of the Natural gas rent(as % of GDP) in Serbia in 2001 to that in 2003?
Your response must be concise. 2.2. What is the ratio of the Natural gas rent(as % of GDP) in Europe(all income levels) in 2001 to that in 2004?
Offer a terse response. 1.08. What is the ratio of the Natural gas rent(as % of GDP) in Middle income in 2001 to that in 2004?
Offer a terse response. 0.86. What is the ratio of the Natural gas rent(as % of GDP) of Chile in 2001 to that in 2004?
Give a very brief answer. 1.31. What is the ratio of the Natural gas rent(as % of GDP) of Serbia in 2001 to that in 2004?
Provide a succinct answer. 2.72. What is the ratio of the Natural gas rent(as % of GDP) in Europe(all income levels) in 2001 to that in 2005?
Keep it short and to the point. 0.75. What is the ratio of the Natural gas rent(as % of GDP) of Middle income in 2001 to that in 2005?
Make the answer very short. 0.63. What is the ratio of the Natural gas rent(as % of GDP) in Chile in 2001 to that in 2005?
Your answer should be very brief. 0.87. What is the ratio of the Natural gas rent(as % of GDP) in Serbia in 2001 to that in 2005?
Your response must be concise. 2.01. What is the ratio of the Natural gas rent(as % of GDP) of Europe(all income levels) in 2001 to that in 2006?
Your answer should be compact. 0.8. What is the ratio of the Natural gas rent(as % of GDP) of Middle income in 2001 to that in 2006?
Ensure brevity in your answer.  0.69. What is the ratio of the Natural gas rent(as % of GDP) in Chile in 2001 to that in 2006?
Provide a short and direct response. 1.16. What is the ratio of the Natural gas rent(as % of GDP) in Serbia in 2001 to that in 2006?
Your response must be concise. 2.37. What is the ratio of the Natural gas rent(as % of GDP) of Europe(all income levels) in 2002 to that in 2003?
Give a very brief answer. 0.68. What is the ratio of the Natural gas rent(as % of GDP) of Middle income in 2002 to that in 2003?
Your answer should be very brief. 0.63. What is the ratio of the Natural gas rent(as % of GDP) of Chile in 2002 to that in 2003?
Make the answer very short. 0.78. What is the ratio of the Natural gas rent(as % of GDP) of Serbia in 2002 to that in 2003?
Provide a short and direct response. 0.95. What is the ratio of the Natural gas rent(as % of GDP) of Europe(all income levels) in 2002 to that in 2004?
Your response must be concise. 0.7. What is the ratio of the Natural gas rent(as % of GDP) of Middle income in 2002 to that in 2004?
Offer a terse response. 0.63. What is the ratio of the Natural gas rent(as % of GDP) in Chile in 2002 to that in 2004?
Provide a succinct answer. 0.94. What is the ratio of the Natural gas rent(as % of GDP) in Serbia in 2002 to that in 2004?
Your response must be concise. 1.18. What is the ratio of the Natural gas rent(as % of GDP) of Europe(all income levels) in 2002 to that in 2005?
Your response must be concise. 0.49. What is the ratio of the Natural gas rent(as % of GDP) of Middle income in 2002 to that in 2005?
Offer a terse response. 0.46. What is the ratio of the Natural gas rent(as % of GDP) in Chile in 2002 to that in 2005?
Your answer should be compact. 0.62. What is the ratio of the Natural gas rent(as % of GDP) in Serbia in 2002 to that in 2005?
Your response must be concise. 0.87. What is the ratio of the Natural gas rent(as % of GDP) in Europe(all income levels) in 2002 to that in 2006?
Your answer should be compact. 0.52. What is the ratio of the Natural gas rent(as % of GDP) in Middle income in 2002 to that in 2006?
Your response must be concise. 0.5. What is the ratio of the Natural gas rent(as % of GDP) in Chile in 2002 to that in 2006?
Give a very brief answer. 0.83. What is the ratio of the Natural gas rent(as % of GDP) of Serbia in 2002 to that in 2006?
Give a very brief answer. 1.03. What is the ratio of the Natural gas rent(as % of GDP) of Europe(all income levels) in 2003 to that in 2004?
Your answer should be very brief. 1.04. What is the ratio of the Natural gas rent(as % of GDP) in Middle income in 2003 to that in 2004?
Your answer should be very brief. 1. What is the ratio of the Natural gas rent(as % of GDP) of Chile in 2003 to that in 2004?
Ensure brevity in your answer.  1.2. What is the ratio of the Natural gas rent(as % of GDP) in Serbia in 2003 to that in 2004?
Make the answer very short. 1.24. What is the ratio of the Natural gas rent(as % of GDP) in Europe(all income levels) in 2003 to that in 2005?
Offer a terse response. 0.73. What is the ratio of the Natural gas rent(as % of GDP) of Middle income in 2003 to that in 2005?
Offer a terse response. 0.73. What is the ratio of the Natural gas rent(as % of GDP) of Chile in 2003 to that in 2005?
Your response must be concise. 0.79. What is the ratio of the Natural gas rent(as % of GDP) in Serbia in 2003 to that in 2005?
Ensure brevity in your answer.  0.91. What is the ratio of the Natural gas rent(as % of GDP) in Europe(all income levels) in 2003 to that in 2006?
Your answer should be compact. 0.77. What is the ratio of the Natural gas rent(as % of GDP) of Middle income in 2003 to that in 2006?
Keep it short and to the point. 0.8. What is the ratio of the Natural gas rent(as % of GDP) of Chile in 2003 to that in 2006?
Offer a very short reply. 1.06. What is the ratio of the Natural gas rent(as % of GDP) of Serbia in 2003 to that in 2006?
Keep it short and to the point. 1.08. What is the ratio of the Natural gas rent(as % of GDP) in Europe(all income levels) in 2004 to that in 2005?
Provide a short and direct response. 0.7. What is the ratio of the Natural gas rent(as % of GDP) of Middle income in 2004 to that in 2005?
Give a very brief answer. 0.73. What is the ratio of the Natural gas rent(as % of GDP) in Chile in 2004 to that in 2005?
Ensure brevity in your answer.  0.66. What is the ratio of the Natural gas rent(as % of GDP) of Serbia in 2004 to that in 2005?
Keep it short and to the point. 0.74. What is the ratio of the Natural gas rent(as % of GDP) in Europe(all income levels) in 2004 to that in 2006?
Make the answer very short. 0.74. What is the ratio of the Natural gas rent(as % of GDP) in Middle income in 2004 to that in 2006?
Give a very brief answer. 0.8. What is the ratio of the Natural gas rent(as % of GDP) in Chile in 2004 to that in 2006?
Your answer should be very brief. 0.88. What is the ratio of the Natural gas rent(as % of GDP) of Serbia in 2004 to that in 2006?
Make the answer very short. 0.87. What is the ratio of the Natural gas rent(as % of GDP) of Europe(all income levels) in 2005 to that in 2006?
Ensure brevity in your answer.  1.06. What is the ratio of the Natural gas rent(as % of GDP) in Middle income in 2005 to that in 2006?
Keep it short and to the point. 1.09. What is the ratio of the Natural gas rent(as % of GDP) in Chile in 2005 to that in 2006?
Provide a short and direct response. 1.34. What is the ratio of the Natural gas rent(as % of GDP) of Serbia in 2005 to that in 2006?
Your answer should be very brief. 1.18. What is the difference between the highest and the second highest Natural gas rent(as % of GDP) of Europe(all income levels)?
Your response must be concise. 0.07. What is the difference between the highest and the second highest Natural gas rent(as % of GDP) in Middle income?
Give a very brief answer. 0.17. What is the difference between the highest and the second highest Natural gas rent(as % of GDP) in Chile?
Offer a terse response. 0.05. What is the difference between the highest and the second highest Natural gas rent(as % of GDP) of Serbia?
Offer a very short reply. 0.82. What is the difference between the highest and the lowest Natural gas rent(as % of GDP) of Europe(all income levels)?
Offer a very short reply. 0.61. What is the difference between the highest and the lowest Natural gas rent(as % of GDP) of Middle income?
Provide a succinct answer. 1.08. What is the difference between the highest and the lowest Natural gas rent(as % of GDP) in Chile?
Keep it short and to the point. 0.14. What is the difference between the highest and the lowest Natural gas rent(as % of GDP) in Serbia?
Offer a terse response. 1.12. 